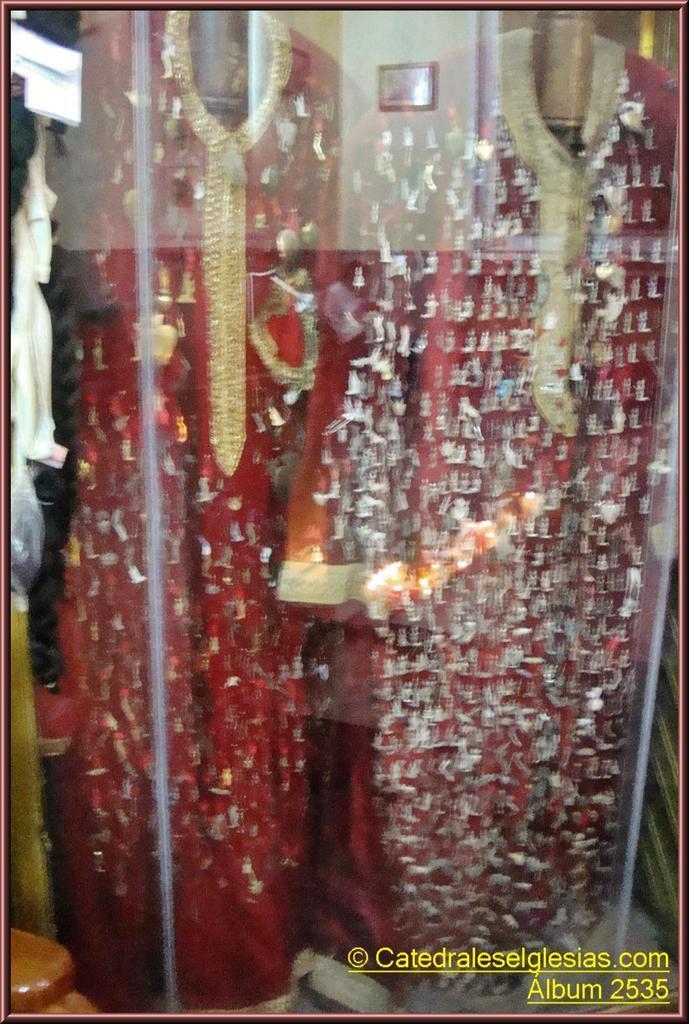In one or two sentences, can you explain what this image depicts? There are dressed to the mannequins in the foreground inside the glass, there is text at the bottom side. 